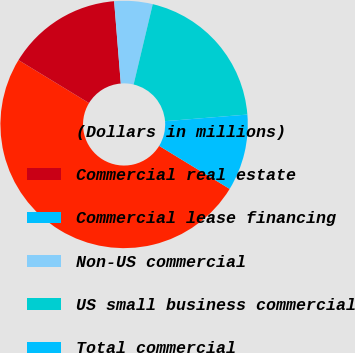<chart> <loc_0><loc_0><loc_500><loc_500><pie_chart><fcel>(Dollars in millions)<fcel>Commercial real estate<fcel>Commercial lease financing<fcel>Non-US commercial<fcel>US small business commercial<fcel>Total commercial<nl><fcel>49.99%<fcel>15.0%<fcel>0.01%<fcel>5.0%<fcel>20.0%<fcel>10.0%<nl></chart> 